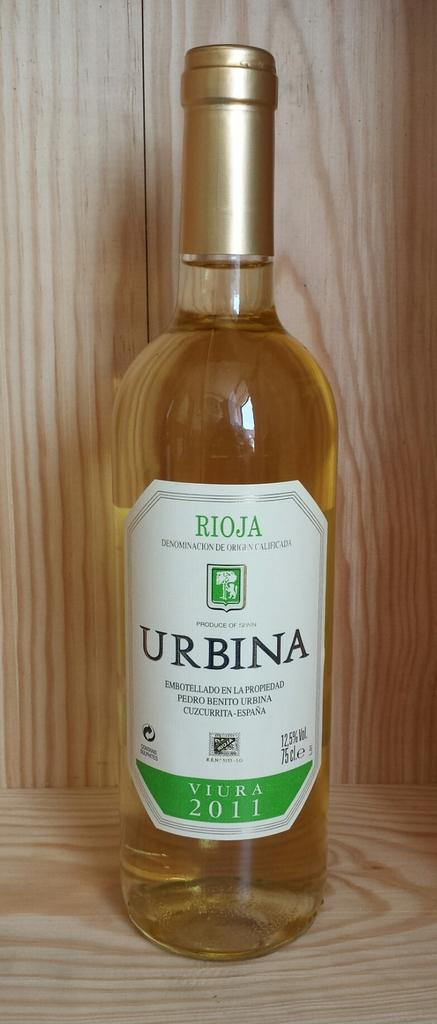<image>
Render a clear and concise summary of the photo. An amber color of Urbina wine from 2011 being displayed on a shelf. 